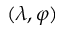<formula> <loc_0><loc_0><loc_500><loc_500>( \lambda , \varphi )</formula> 